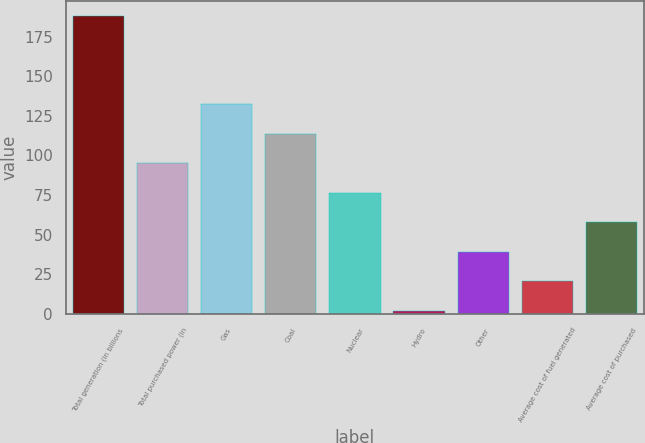Convert chart. <chart><loc_0><loc_0><loc_500><loc_500><bar_chart><fcel>Total generation (in billions<fcel>Total purchased power (in<fcel>Gas<fcel>Coal<fcel>Nuclear<fcel>Hydro<fcel>Other<fcel>Average cost of fuel generated<fcel>Average cost of purchased<nl><fcel>188<fcel>95<fcel>132.2<fcel>113.6<fcel>76.4<fcel>2<fcel>39.2<fcel>20.6<fcel>57.8<nl></chart> 